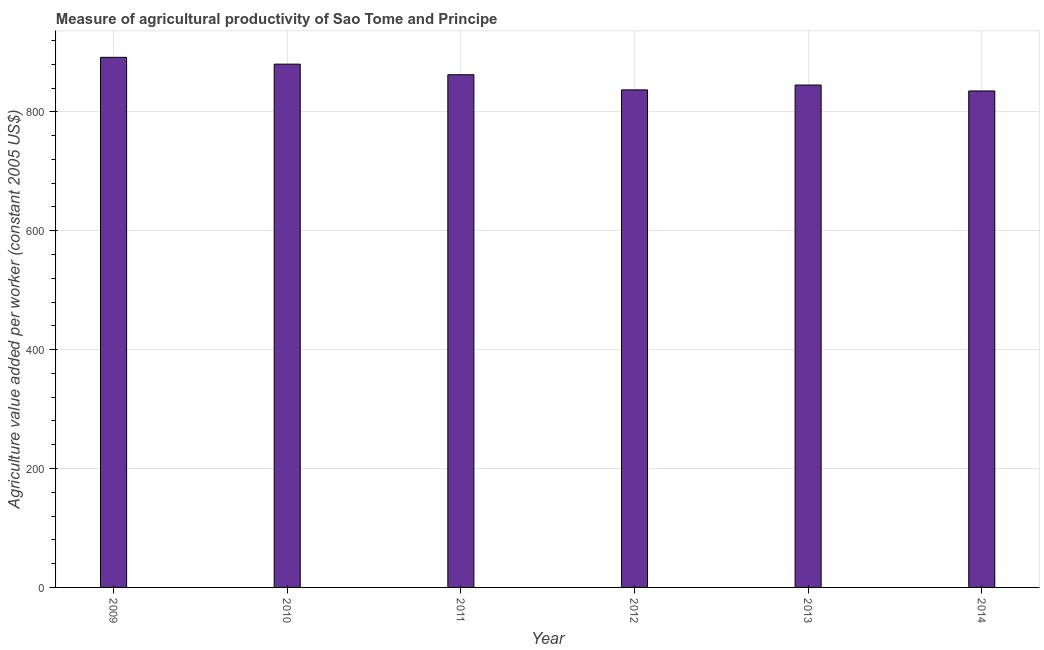Does the graph contain any zero values?
Keep it short and to the point. No. What is the title of the graph?
Offer a very short reply. Measure of agricultural productivity of Sao Tome and Principe. What is the label or title of the Y-axis?
Your answer should be very brief. Agriculture value added per worker (constant 2005 US$). What is the agriculture value added per worker in 2010?
Give a very brief answer. 880.29. Across all years, what is the maximum agriculture value added per worker?
Keep it short and to the point. 891.77. Across all years, what is the minimum agriculture value added per worker?
Your answer should be very brief. 835.18. In which year was the agriculture value added per worker maximum?
Ensure brevity in your answer.  2009. What is the sum of the agriculture value added per worker?
Keep it short and to the point. 5151.91. What is the difference between the agriculture value added per worker in 2009 and 2014?
Offer a terse response. 56.59. What is the average agriculture value added per worker per year?
Make the answer very short. 858.65. What is the median agriculture value added per worker?
Ensure brevity in your answer.  853.83. In how many years, is the agriculture value added per worker greater than 280 US$?
Ensure brevity in your answer.  6. What is the ratio of the agriculture value added per worker in 2009 to that in 2014?
Offer a very short reply. 1.07. Is the agriculture value added per worker in 2009 less than that in 2014?
Offer a very short reply. No. What is the difference between the highest and the second highest agriculture value added per worker?
Ensure brevity in your answer.  11.48. Is the sum of the agriculture value added per worker in 2012 and 2013 greater than the maximum agriculture value added per worker across all years?
Give a very brief answer. Yes. What is the difference between the highest and the lowest agriculture value added per worker?
Make the answer very short. 56.59. Are all the bars in the graph horizontal?
Make the answer very short. No. What is the difference between two consecutive major ticks on the Y-axis?
Keep it short and to the point. 200. What is the Agriculture value added per worker (constant 2005 US$) of 2009?
Ensure brevity in your answer.  891.77. What is the Agriculture value added per worker (constant 2005 US$) in 2010?
Offer a terse response. 880.29. What is the Agriculture value added per worker (constant 2005 US$) in 2011?
Keep it short and to the point. 862.51. What is the Agriculture value added per worker (constant 2005 US$) of 2012?
Keep it short and to the point. 837. What is the Agriculture value added per worker (constant 2005 US$) in 2013?
Your response must be concise. 845.16. What is the Agriculture value added per worker (constant 2005 US$) of 2014?
Your answer should be very brief. 835.18. What is the difference between the Agriculture value added per worker (constant 2005 US$) in 2009 and 2010?
Give a very brief answer. 11.48. What is the difference between the Agriculture value added per worker (constant 2005 US$) in 2009 and 2011?
Ensure brevity in your answer.  29.26. What is the difference between the Agriculture value added per worker (constant 2005 US$) in 2009 and 2012?
Offer a terse response. 54.77. What is the difference between the Agriculture value added per worker (constant 2005 US$) in 2009 and 2013?
Your answer should be compact. 46.61. What is the difference between the Agriculture value added per worker (constant 2005 US$) in 2009 and 2014?
Give a very brief answer. 56.59. What is the difference between the Agriculture value added per worker (constant 2005 US$) in 2010 and 2011?
Your answer should be very brief. 17.79. What is the difference between the Agriculture value added per worker (constant 2005 US$) in 2010 and 2012?
Give a very brief answer. 43.29. What is the difference between the Agriculture value added per worker (constant 2005 US$) in 2010 and 2013?
Provide a succinct answer. 35.13. What is the difference between the Agriculture value added per worker (constant 2005 US$) in 2010 and 2014?
Provide a short and direct response. 45.11. What is the difference between the Agriculture value added per worker (constant 2005 US$) in 2011 and 2012?
Keep it short and to the point. 25.51. What is the difference between the Agriculture value added per worker (constant 2005 US$) in 2011 and 2013?
Provide a short and direct response. 17.34. What is the difference between the Agriculture value added per worker (constant 2005 US$) in 2011 and 2014?
Make the answer very short. 27.33. What is the difference between the Agriculture value added per worker (constant 2005 US$) in 2012 and 2013?
Offer a very short reply. -8.16. What is the difference between the Agriculture value added per worker (constant 2005 US$) in 2012 and 2014?
Your answer should be compact. 1.82. What is the difference between the Agriculture value added per worker (constant 2005 US$) in 2013 and 2014?
Give a very brief answer. 9.98. What is the ratio of the Agriculture value added per worker (constant 2005 US$) in 2009 to that in 2011?
Your response must be concise. 1.03. What is the ratio of the Agriculture value added per worker (constant 2005 US$) in 2009 to that in 2012?
Offer a very short reply. 1.06. What is the ratio of the Agriculture value added per worker (constant 2005 US$) in 2009 to that in 2013?
Provide a short and direct response. 1.05. What is the ratio of the Agriculture value added per worker (constant 2005 US$) in 2009 to that in 2014?
Keep it short and to the point. 1.07. What is the ratio of the Agriculture value added per worker (constant 2005 US$) in 2010 to that in 2011?
Your answer should be very brief. 1.02. What is the ratio of the Agriculture value added per worker (constant 2005 US$) in 2010 to that in 2012?
Offer a very short reply. 1.05. What is the ratio of the Agriculture value added per worker (constant 2005 US$) in 2010 to that in 2013?
Keep it short and to the point. 1.04. What is the ratio of the Agriculture value added per worker (constant 2005 US$) in 2010 to that in 2014?
Your answer should be compact. 1.05. What is the ratio of the Agriculture value added per worker (constant 2005 US$) in 2011 to that in 2013?
Keep it short and to the point. 1.02. What is the ratio of the Agriculture value added per worker (constant 2005 US$) in 2011 to that in 2014?
Provide a short and direct response. 1.03. 